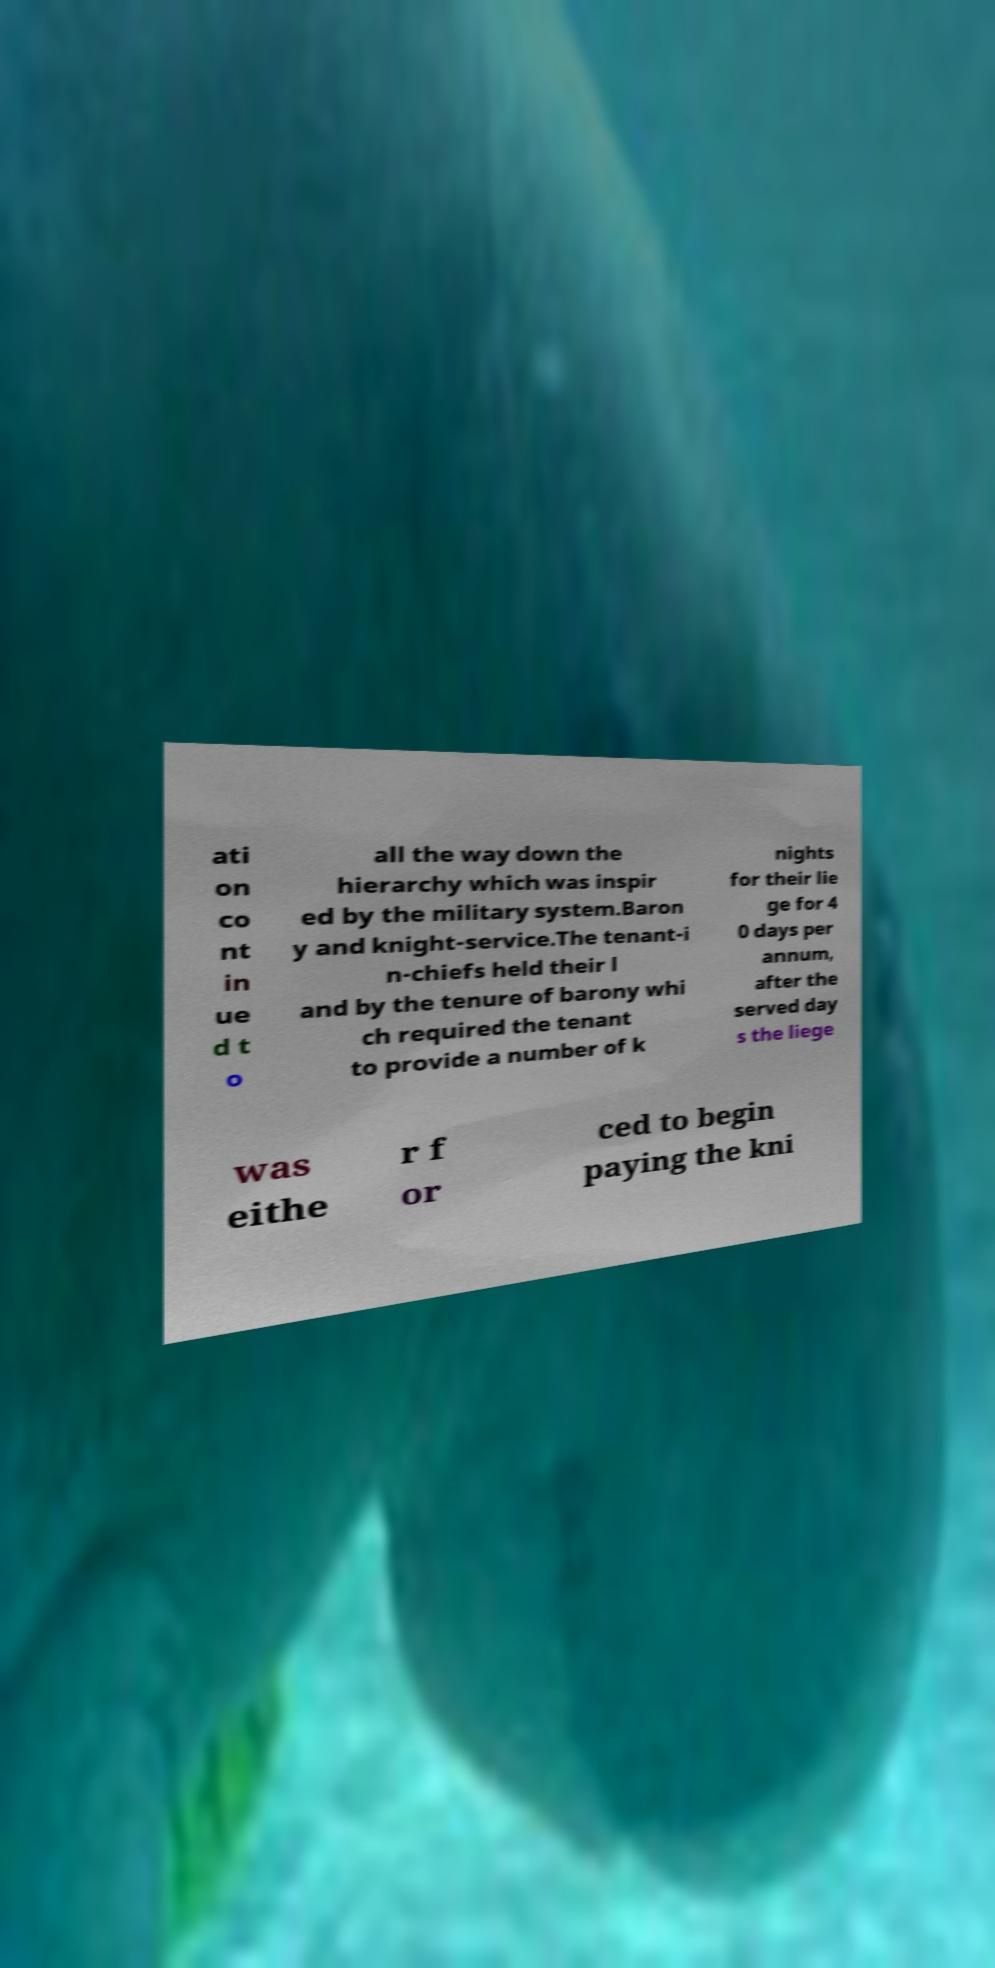There's text embedded in this image that I need extracted. Can you transcribe it verbatim? ati on co nt in ue d t o all the way down the hierarchy which was inspir ed by the military system.Baron y and knight-service.The tenant-i n-chiefs held their l and by the tenure of barony whi ch required the tenant to provide a number of k nights for their lie ge for 4 0 days per annum, after the served day s the liege was eithe r f or ced to begin paying the kni 